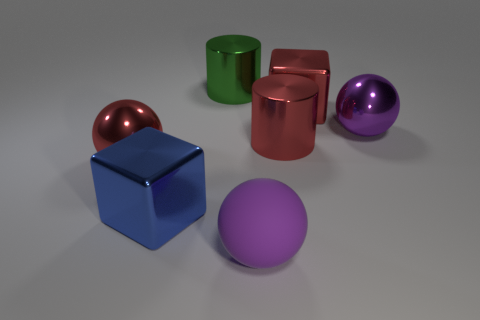There is a large ball that is the same color as the rubber object; what is its material?
Provide a short and direct response. Metal. Is there anything else of the same color as the big matte thing?
Keep it short and to the point. Yes. The other thing that is the same shape as the green object is what color?
Offer a terse response. Red. There is a ball that is to the right of the green object and behind the large rubber object; how big is it?
Give a very brief answer. Large. There is a large blue object that is in front of the big red ball; is it the same shape as the large red metallic object that is to the left of the red metallic cylinder?
Your answer should be very brief. No. The big object that is the same color as the big matte sphere is what shape?
Your answer should be very brief. Sphere. What number of big red cylinders have the same material as the green thing?
Your response must be concise. 1. There is a object that is to the right of the big rubber object and in front of the purple shiny object; what is its shape?
Provide a succinct answer. Cylinder. Are the blue thing that is to the left of the big green metal cylinder and the green thing made of the same material?
Your response must be concise. Yes. Is there anything else that has the same material as the big red cylinder?
Your response must be concise. Yes. 